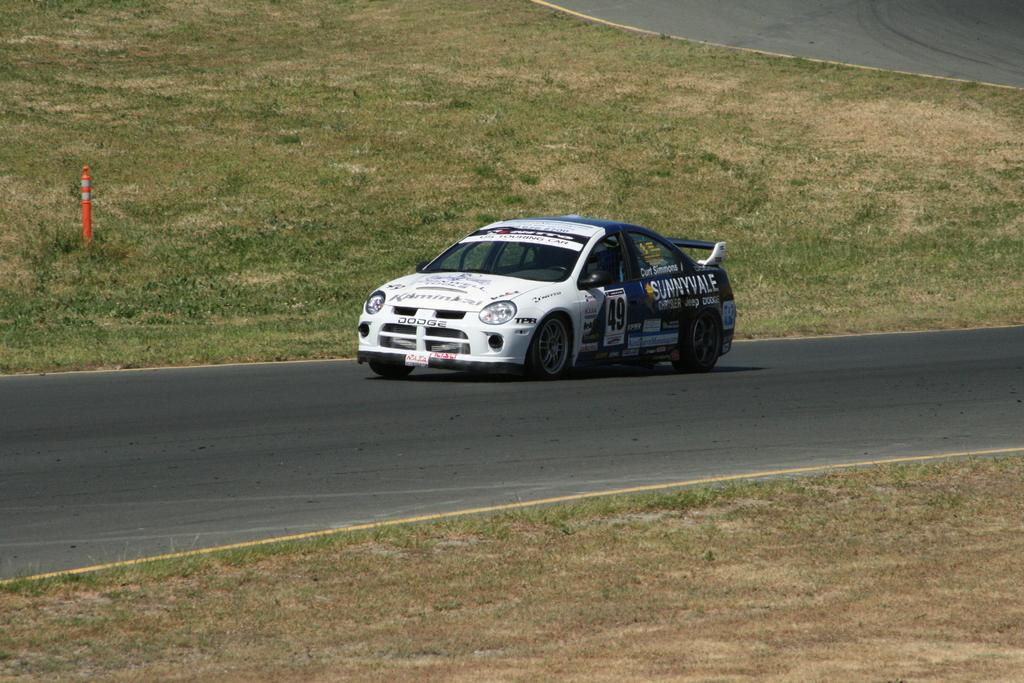What is the main subject of the image? The main subject of the image is a car. Can you describe the car's appearance? The car is white and blue. What is at the bottom of the image? There is a road at the bottom of the image. What type of vegetation can be seen in the image? There is green grass visible in the image. Where is the tramp sitting in the image? There is no tramp present in the image. What type of crown is the queen wearing in the image? There is no queen or crown present in the image. 